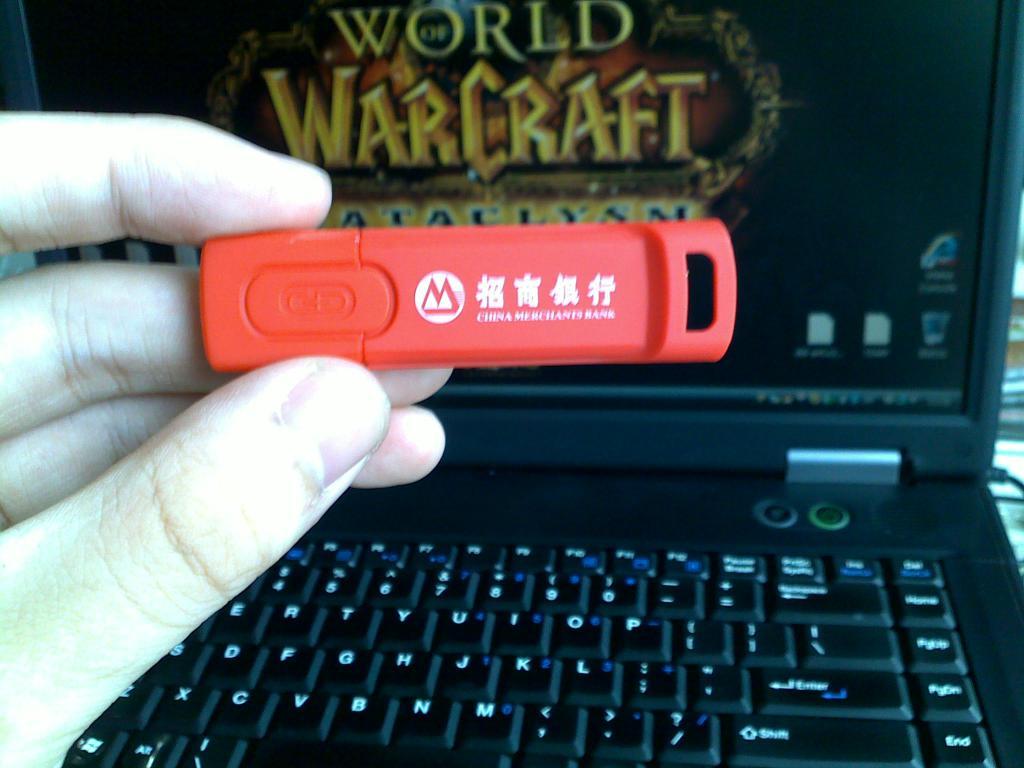What game is on the laptop?
Provide a succinct answer. World of warcraft. 